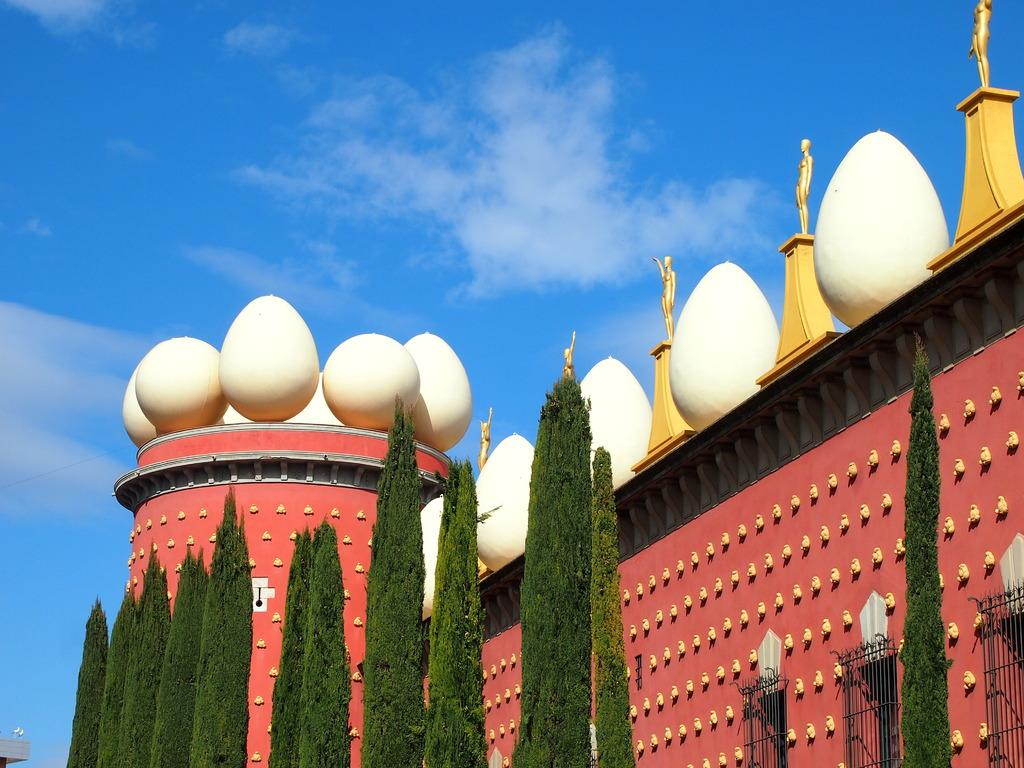What type of vegetation is in the middle of the image? There are trees in the middle of the image. What type of structure can be seen in the image? There is a building in the image. What unique feature can be observed on the building? The building has egg-shaped structures on it. What is visible at the top of the image? The sky is blue in color and visible at the top of the image. What type of wax is being used to create the egg-shaped structures on the building? There is no mention of wax or any material used to create the egg-shaped structures on the building in the image. Is there a meeting taking place in the building in the image? The image does not provide any information about a meeting or any activities happening inside the building. 